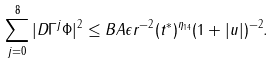Convert formula to latex. <formula><loc_0><loc_0><loc_500><loc_500>\sum _ { j = 0 } ^ { 8 } | D \Gamma ^ { j } \Phi | ^ { 2 } \leq B A \epsilon r ^ { - 2 } ( t ^ { * } ) ^ { \eta _ { 1 4 } } ( 1 + | u | ) ^ { - 2 } .</formula> 